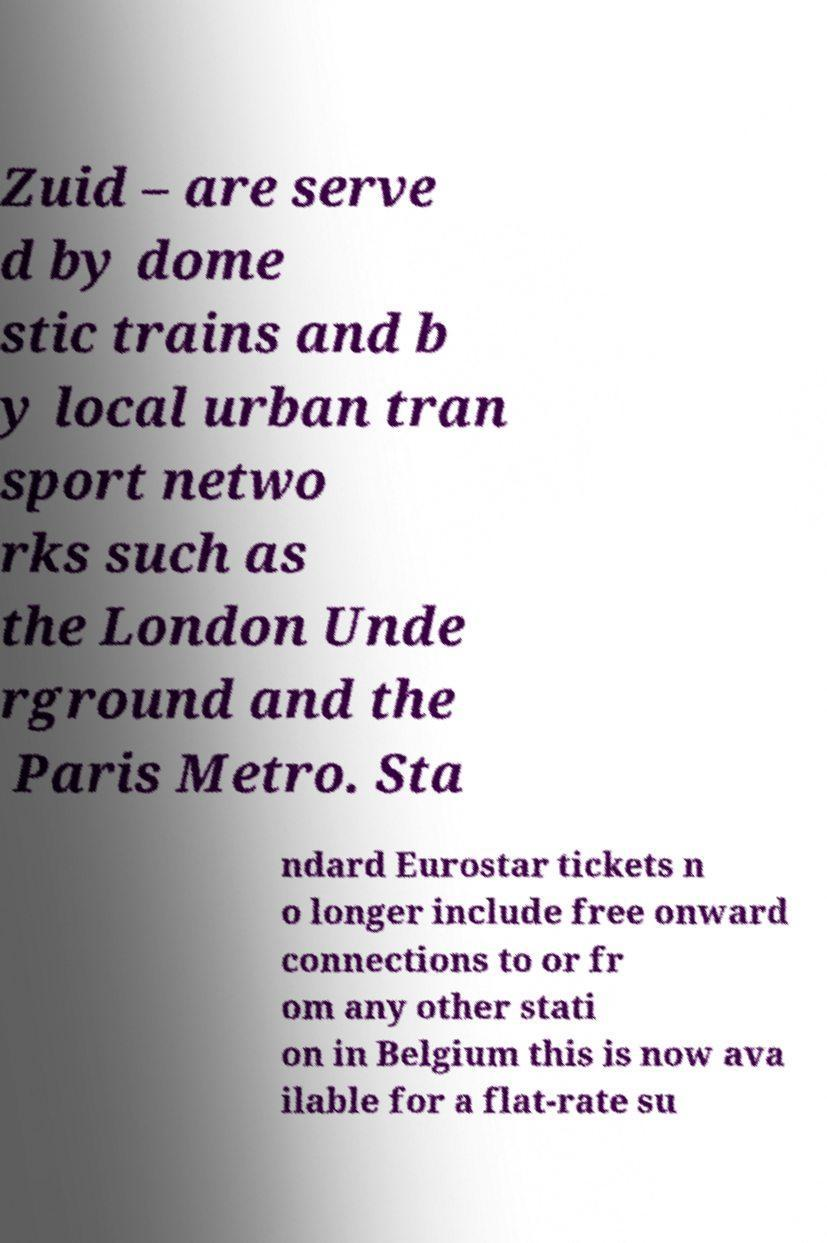For documentation purposes, I need the text within this image transcribed. Could you provide that? Zuid – are serve d by dome stic trains and b y local urban tran sport netwo rks such as the London Unde rground and the Paris Metro. Sta ndard Eurostar tickets n o longer include free onward connections to or fr om any other stati on in Belgium this is now ava ilable for a flat-rate su 